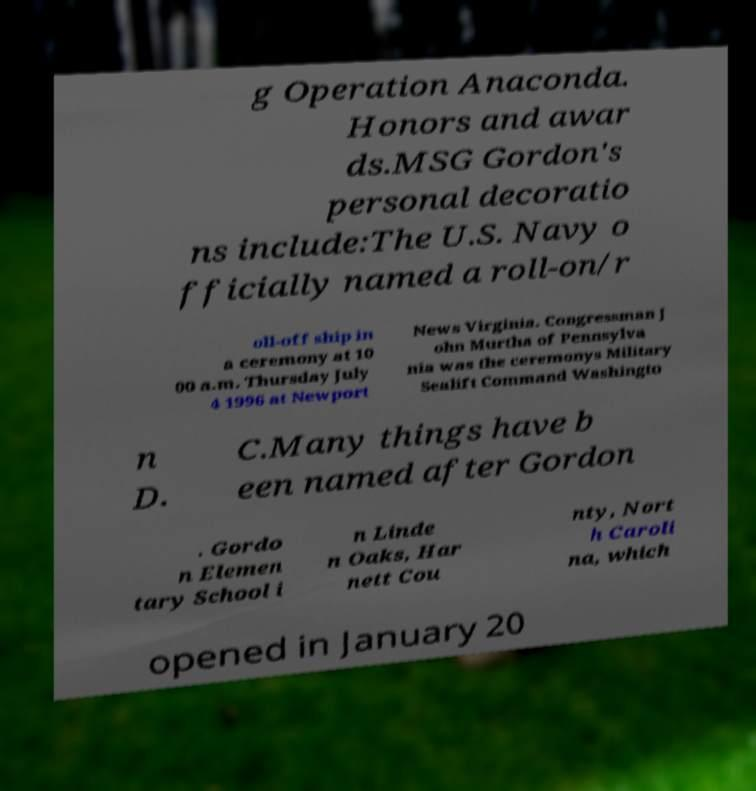Could you extract and type out the text from this image? g Operation Anaconda. Honors and awar ds.MSG Gordon's personal decoratio ns include:The U.S. Navy o fficially named a roll-on/r oll-off ship in a ceremony at 10 00 a.m. Thursday July 4 1996 at Newport News Virginia. Congressman J ohn Murtha of Pennsylva nia was the ceremonys Military Sealift Command Washingto n D. C.Many things have b een named after Gordon . Gordo n Elemen tary School i n Linde n Oaks, Har nett Cou nty, Nort h Caroli na, which opened in January 20 